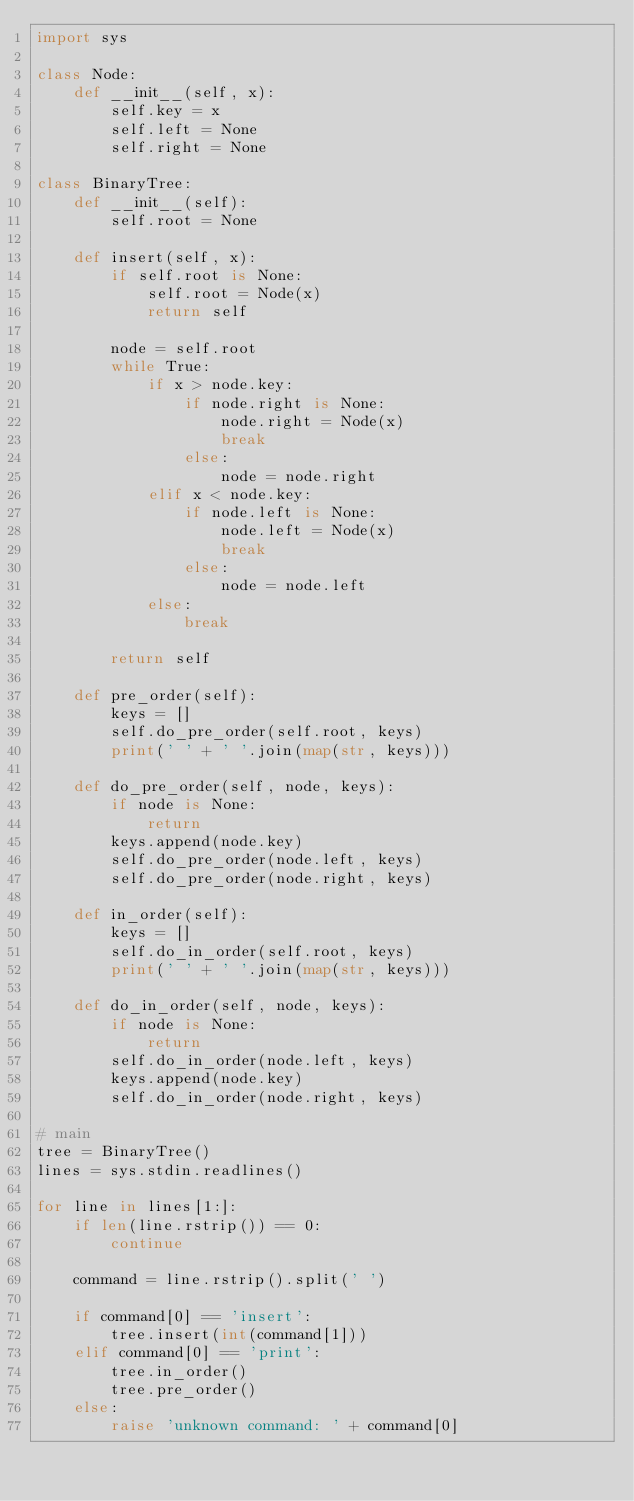<code> <loc_0><loc_0><loc_500><loc_500><_Python_>import sys

class Node:
    def __init__(self, x):
        self.key = x
        self.left = None
        self.right = None

class BinaryTree:
    def __init__(self):
        self.root = None

    def insert(self, x):
        if self.root is None:
            self.root = Node(x)
            return self

        node = self.root
        while True:
            if x > node.key:
                if node.right is None:
                    node.right = Node(x)
                    break
                else:
                    node = node.right
            elif x < node.key:
                if node.left is None:
                    node.left = Node(x)
                    break
                else:
                    node = node.left
            else:
                break

        return self

    def pre_order(self):
        keys = []
        self.do_pre_order(self.root, keys)
        print(' ' + ' '.join(map(str, keys)))

    def do_pre_order(self, node, keys):
        if node is None:
            return
        keys.append(node.key)
        self.do_pre_order(node.left, keys)
        self.do_pre_order(node.right, keys)

    def in_order(self):
        keys = []
        self.do_in_order(self.root, keys)
        print(' ' + ' '.join(map(str, keys)))

    def do_in_order(self, node, keys):
        if node is None:
            return
        self.do_in_order(node.left, keys)
        keys.append(node.key)
        self.do_in_order(node.right, keys)

# main
tree = BinaryTree()
lines = sys.stdin.readlines()

for line in lines[1:]:
    if len(line.rstrip()) == 0:
        continue

    command = line.rstrip().split(' ')

    if command[0] == 'insert':
        tree.insert(int(command[1]))
    elif command[0] == 'print':
        tree.in_order()
        tree.pre_order()
    else:
        raise 'unknown command: ' + command[0]</code> 